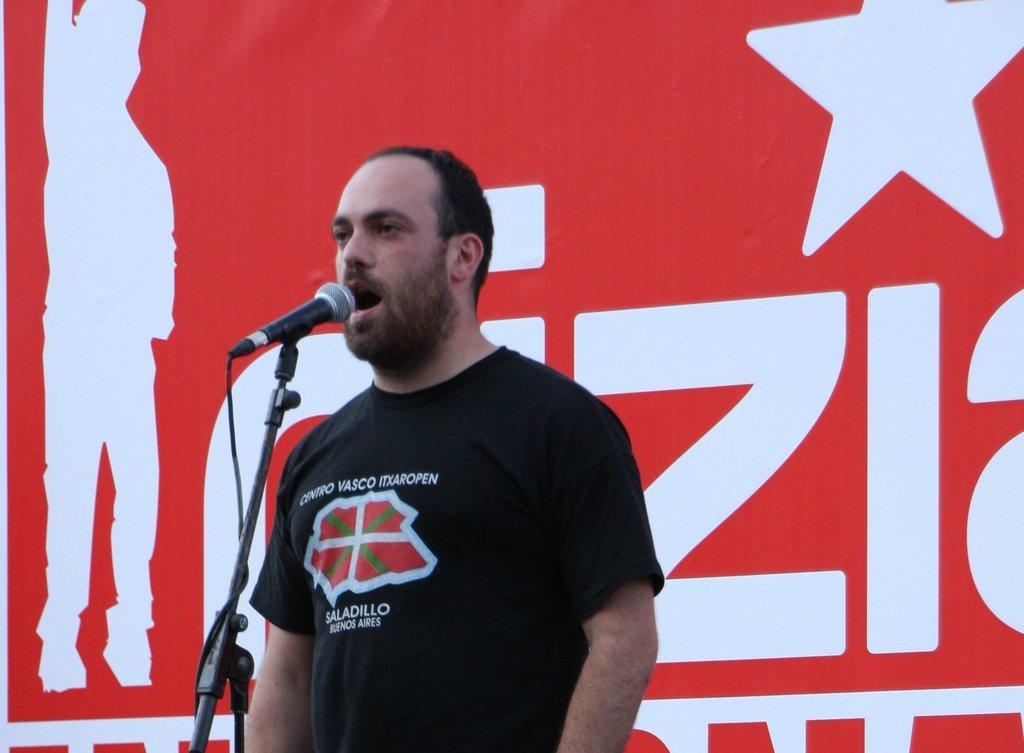Please provide a concise description of this image. In this picture we can see a man is speaking in front of the microphone. 